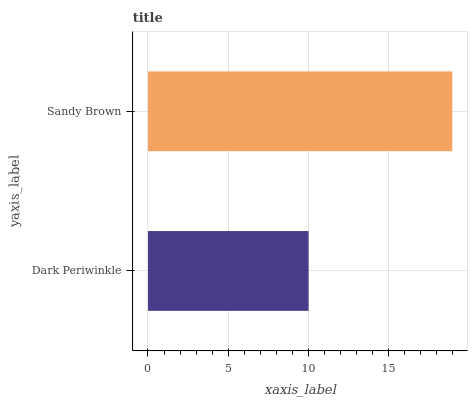Is Dark Periwinkle the minimum?
Answer yes or no. Yes. Is Sandy Brown the maximum?
Answer yes or no. Yes. Is Sandy Brown the minimum?
Answer yes or no. No. Is Sandy Brown greater than Dark Periwinkle?
Answer yes or no. Yes. Is Dark Periwinkle less than Sandy Brown?
Answer yes or no. Yes. Is Dark Periwinkle greater than Sandy Brown?
Answer yes or no. No. Is Sandy Brown less than Dark Periwinkle?
Answer yes or no. No. Is Sandy Brown the high median?
Answer yes or no. Yes. Is Dark Periwinkle the low median?
Answer yes or no. Yes. Is Dark Periwinkle the high median?
Answer yes or no. No. Is Sandy Brown the low median?
Answer yes or no. No. 